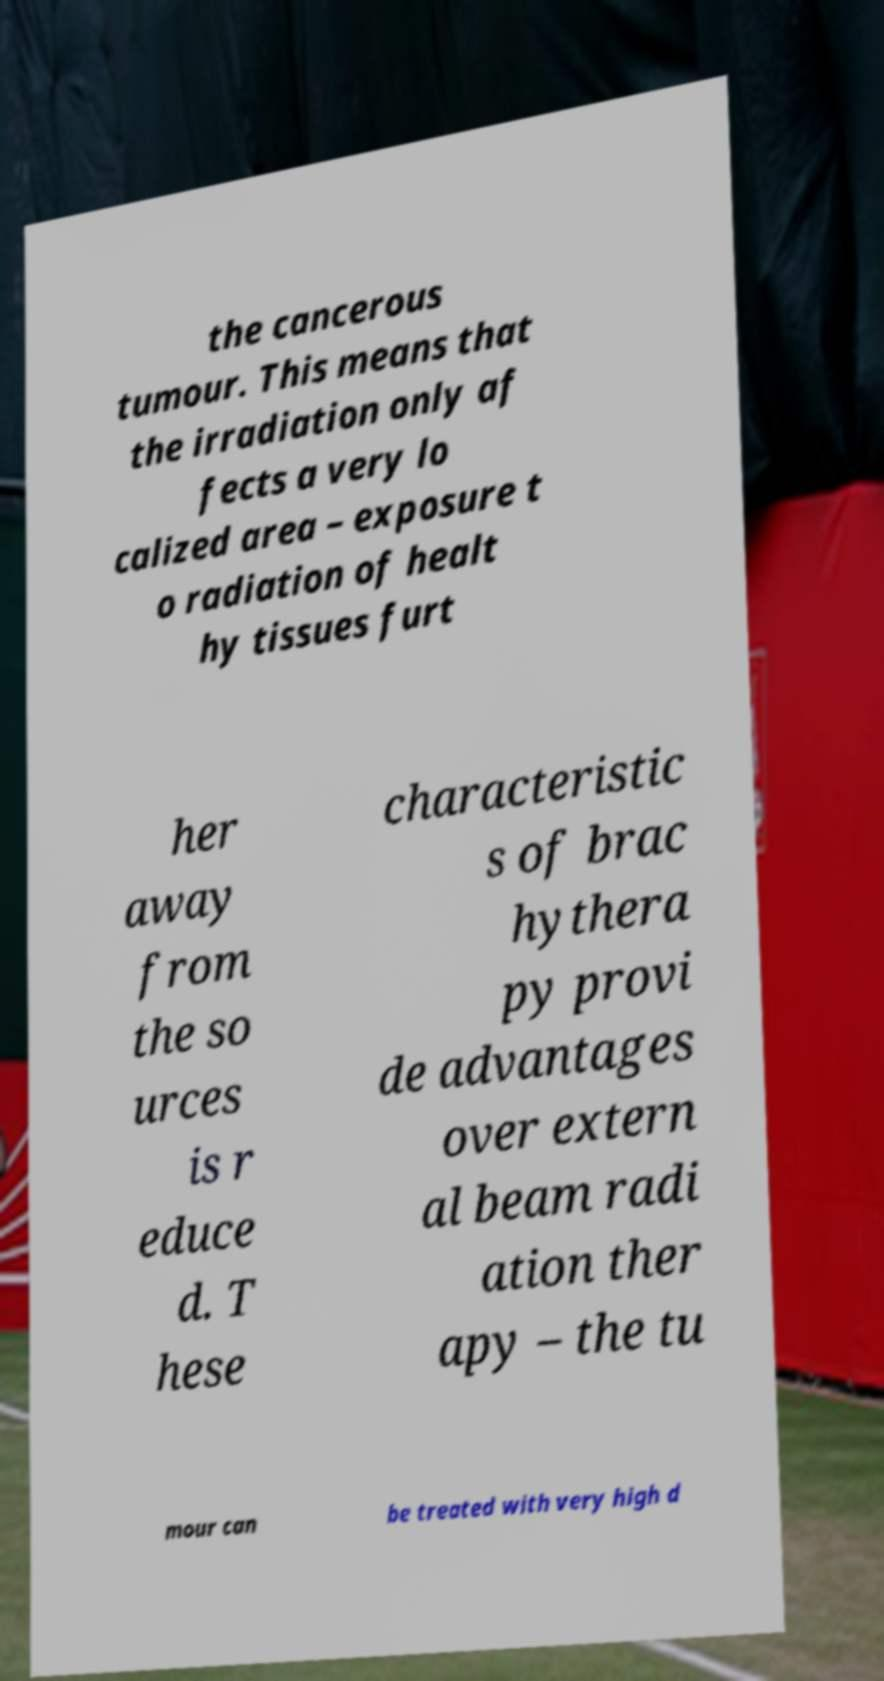I need the written content from this picture converted into text. Can you do that? the cancerous tumour. This means that the irradiation only af fects a very lo calized area – exposure t o radiation of healt hy tissues furt her away from the so urces is r educe d. T hese characteristic s of brac hythera py provi de advantages over extern al beam radi ation ther apy – the tu mour can be treated with very high d 